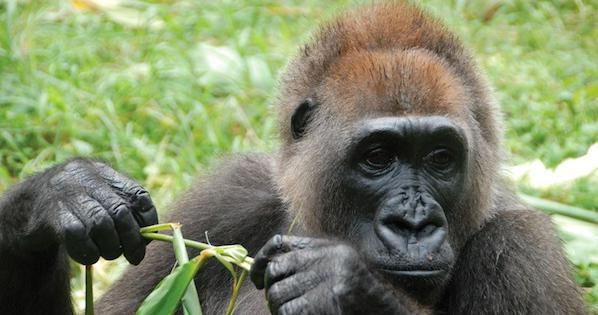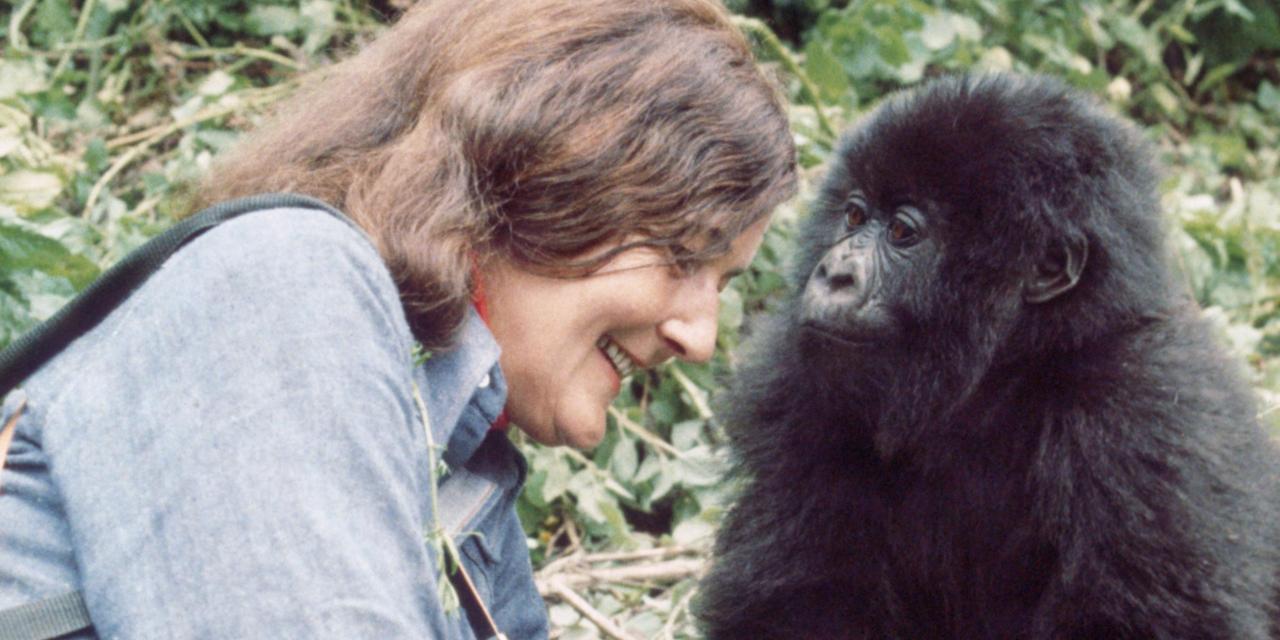The first image is the image on the left, the second image is the image on the right. Given the left and right images, does the statement "Each image shows one person to the right of one gorilla, and the right image shows a gorilla face-to-face with and touching a person." hold true? Answer yes or no. No. The first image is the image on the left, the second image is the image on the right. Evaluate the accuracy of this statement regarding the images: "The left and right image contains the same number gorillas on the left and people on the right.". Is it true? Answer yes or no. No. 